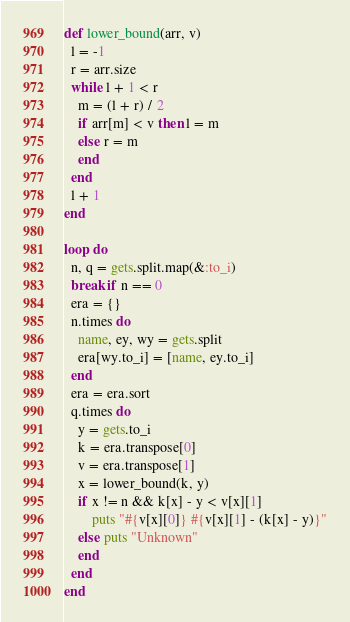<code> <loc_0><loc_0><loc_500><loc_500><_Ruby_>def lower_bound(arr, v)
  l = -1
  r = arr.size
  while l + 1 < r
    m = (l + r) / 2
    if arr[m] < v then l = m
    else r = m
    end
  end
  l + 1
end

loop do
  n, q = gets.split.map(&:to_i)
  break if n == 0
  era = {}
  n.times do
    name, ey, wy = gets.split
    era[wy.to_i] = [name, ey.to_i]
  end
  era = era.sort
  q.times do
    y = gets.to_i
    k = era.transpose[0]
    v = era.transpose[1]
    x = lower_bound(k, y)
    if x != n && k[x] - y < v[x][1]
        puts "#{v[x][0]} #{v[x][1] - (k[x] - y)}"
    else puts "Unknown"
    end
  end
end</code> 